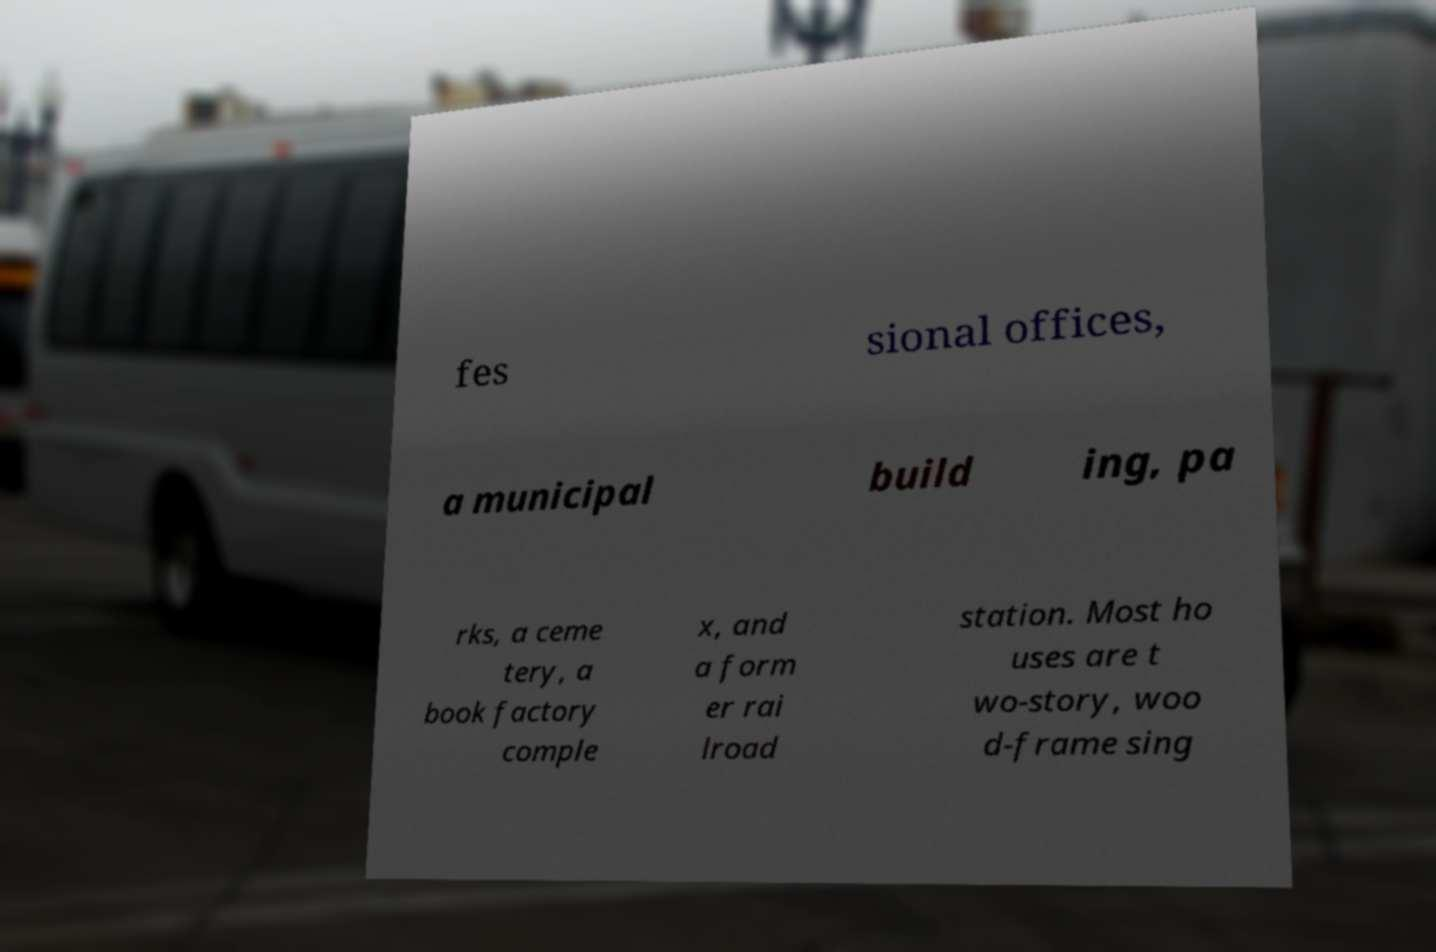Please read and relay the text visible in this image. What does it say? fes sional offices, a municipal build ing, pa rks, a ceme tery, a book factory comple x, and a form er rai lroad station. Most ho uses are t wo-story, woo d-frame sing 